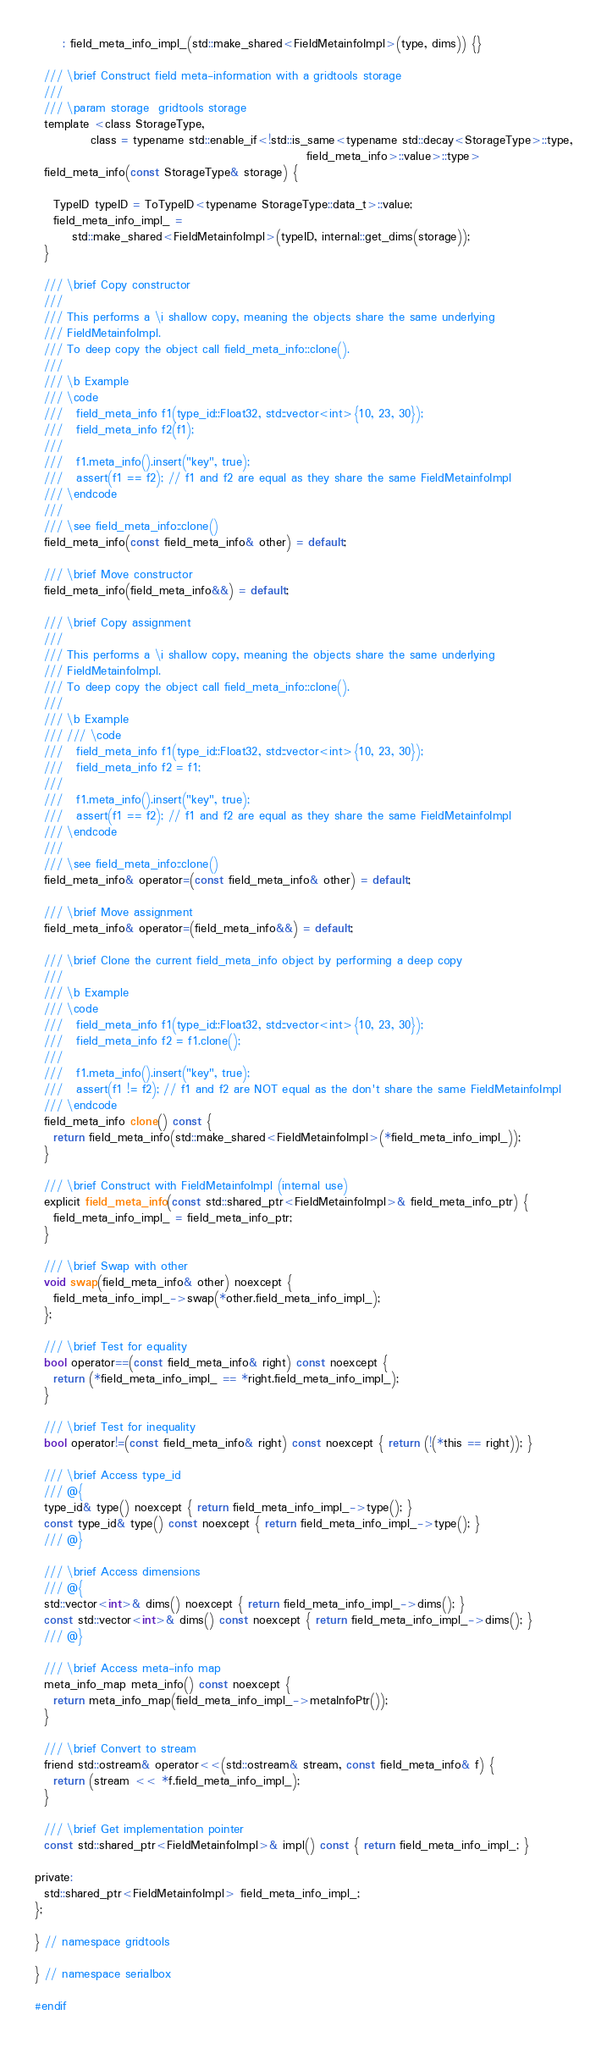<code> <loc_0><loc_0><loc_500><loc_500><_C_>      : field_meta_info_impl_(std::make_shared<FieldMetainfoImpl>(type, dims)) {}

  /// \brief Construct field meta-information with a gridtools storage
  ///
  /// \param storage  gridtools storage
  template <class StorageType,
            class = typename std::enable_if<!std::is_same<typename std::decay<StorageType>::type,
                                                          field_meta_info>::value>::type>
  field_meta_info(const StorageType& storage) {

    TypeID typeID = ToTypeID<typename StorageType::data_t>::value;
    field_meta_info_impl_ =
        std::make_shared<FieldMetainfoImpl>(typeID, internal::get_dims(storage));
  }

  /// \brief Copy constructor
  ///
  /// This performs a \i shallow copy, meaning the objects share the same underlying
  /// FieldMetainfoImpl.
  /// To deep copy the object call field_meta_info::clone().
  ///
  /// \b Example
  /// \code
  ///   field_meta_info f1(type_id::Float32, std::vector<int>{10, 23, 30});
  ///   field_meta_info f2(f1);
  ///
  ///   f1.meta_info().insert("key", true);
  ///   assert(f1 == f2); // f1 and f2 are equal as they share the same FieldMetainfoImpl
  /// \endcode
  ///
  /// \see field_meta_info::clone()
  field_meta_info(const field_meta_info& other) = default;

  /// \brief Move constructor
  field_meta_info(field_meta_info&&) = default;

  /// \brief Copy assignment
  ///
  /// This performs a \i shallow copy, meaning the objects share the same underlying
  /// FieldMetainfoImpl.
  /// To deep copy the object call field_meta_info::clone().
  ///
  /// \b Example
  /// /// \code
  ///   field_meta_info f1(type_id::Float32, std::vector<int>{10, 23, 30});
  ///   field_meta_info f2 = f1;
  ///
  ///   f1.meta_info().insert("key", true);
  ///   assert(f1 == f2); // f1 and f2 are equal as they share the same FieldMetainfoImpl
  /// \endcode
  ///
  /// \see field_meta_info::clone()
  field_meta_info& operator=(const field_meta_info& other) = default;

  /// \brief Move assignment
  field_meta_info& operator=(field_meta_info&&) = default;

  /// \brief Clone the current field_meta_info object by performing a deep copy
  ///
  /// \b Example
  /// \code
  ///   field_meta_info f1(type_id::Float32, std::vector<int>{10, 23, 30});
  ///   field_meta_info f2 = f1.clone();
  ///
  ///   f1.meta_info().insert("key", true);
  ///   assert(f1 != f2); // f1 and f2 are NOT equal as the don't share the same FieldMetainfoImpl
  /// \endcode
  field_meta_info clone() const {
    return field_meta_info(std::make_shared<FieldMetainfoImpl>(*field_meta_info_impl_));
  }

  /// \brief Construct with FieldMetainfoImpl (internal use)
  explicit field_meta_info(const std::shared_ptr<FieldMetainfoImpl>& field_meta_info_ptr) {
    field_meta_info_impl_ = field_meta_info_ptr;
  }

  /// \brief Swap with other
  void swap(field_meta_info& other) noexcept {
    field_meta_info_impl_->swap(*other.field_meta_info_impl_);
  };

  /// \brief Test for equality
  bool operator==(const field_meta_info& right) const noexcept {
    return (*field_meta_info_impl_ == *right.field_meta_info_impl_);
  }

  /// \brief Test for inequality
  bool operator!=(const field_meta_info& right) const noexcept { return (!(*this == right)); }

  /// \brief Access type_id
  /// @{
  type_id& type() noexcept { return field_meta_info_impl_->type(); }
  const type_id& type() const noexcept { return field_meta_info_impl_->type(); }
  /// @}

  /// \brief Access dimensions
  /// @{
  std::vector<int>& dims() noexcept { return field_meta_info_impl_->dims(); }
  const std::vector<int>& dims() const noexcept { return field_meta_info_impl_->dims(); }
  /// @}

  /// \brief Access meta-info map
  meta_info_map meta_info() const noexcept {
    return meta_info_map(field_meta_info_impl_->metaInfoPtr());
  }

  /// \brief Convert to stream
  friend std::ostream& operator<<(std::ostream& stream, const field_meta_info& f) {
    return (stream << *f.field_meta_info_impl_);
  }

  /// \brief Get implementation pointer
  const std::shared_ptr<FieldMetainfoImpl>& impl() const { return field_meta_info_impl_; }

private:
  std::shared_ptr<FieldMetainfoImpl> field_meta_info_impl_;
};

} // namespace gridtools

} // namespace serialbox

#endif
</code> 